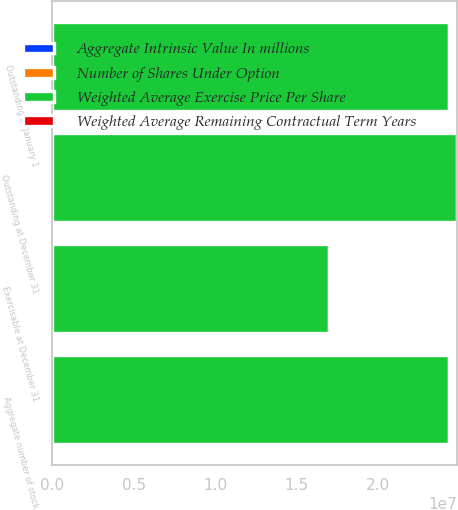Convert chart. <chart><loc_0><loc_0><loc_500><loc_500><stacked_bar_chart><ecel><fcel>Outstanding at January 1<fcel>Outstanding at December 31<fcel>Aggregate number of stock<fcel>Exercisable at December 31<nl><fcel>Weighted Average Exercise Price Per Share<fcel>2.43818e+07<fcel>2.48915e+07<fcel>2.43902e+07<fcel>1.70348e+07<nl><fcel>Weighted Average Remaining Contractual Term Years<fcel>31.83<fcel>34.68<fcel>34.48<fcel>30.66<nl><fcel>Number of Shares Under Option<fcel>6.92<fcel>6.58<fcel>6.54<fcel>5.72<nl><fcel>Aggregate Intrinsic Value In millions<fcel>419<fcel>606<fcel>598<fcel>483<nl></chart> 